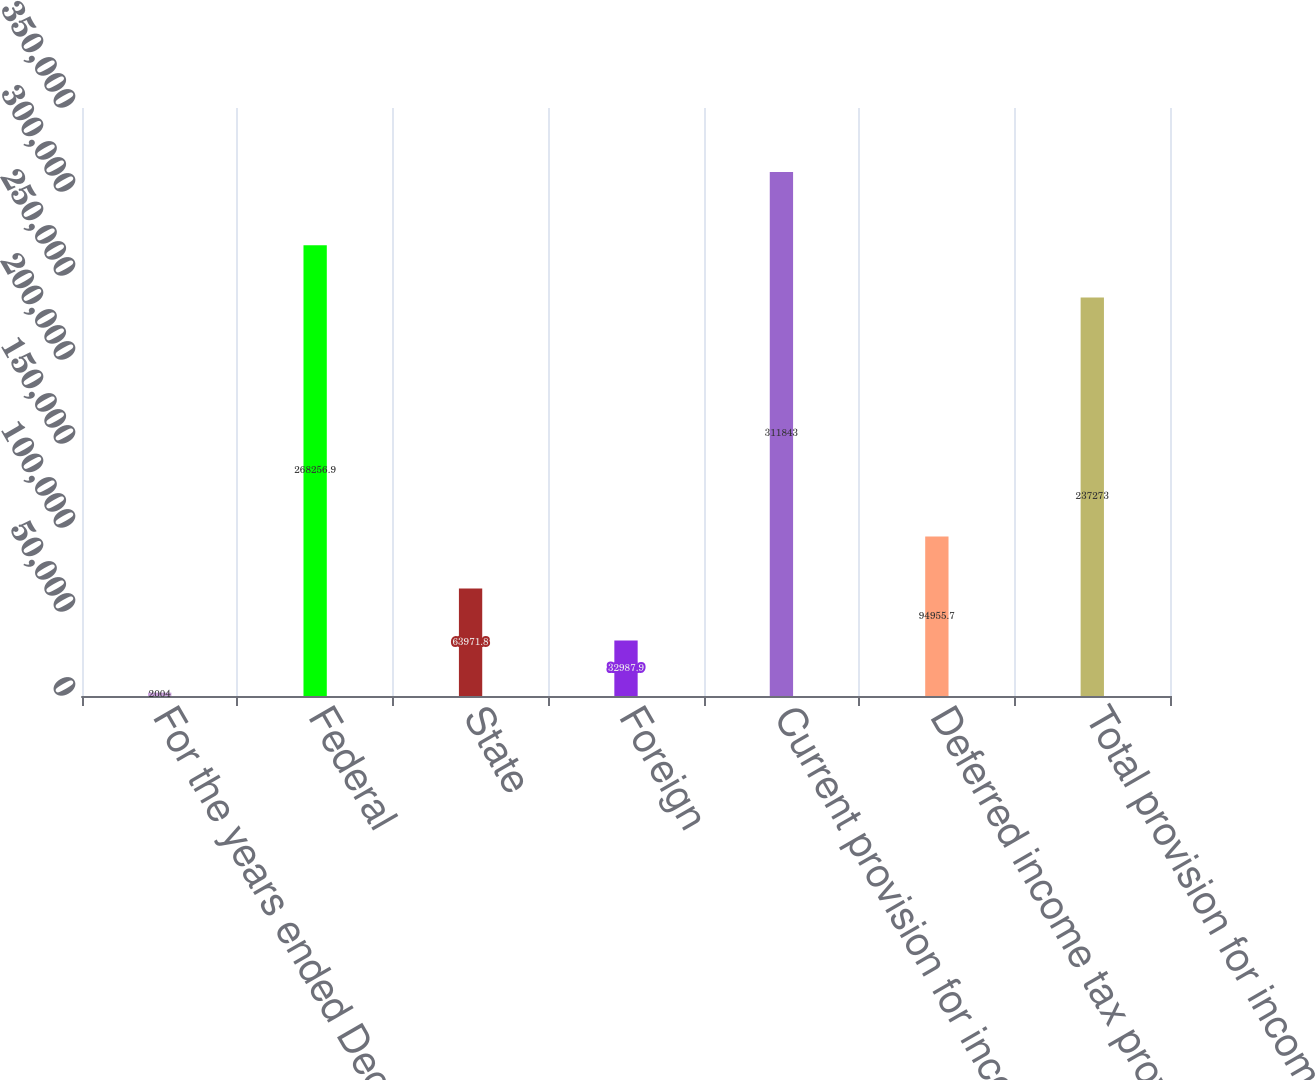<chart> <loc_0><loc_0><loc_500><loc_500><bar_chart><fcel>For the years ended December<fcel>Federal<fcel>State<fcel>Foreign<fcel>Current provision for income<fcel>Deferred income tax provision<fcel>Total provision for income<nl><fcel>2004<fcel>268257<fcel>63971.8<fcel>32987.9<fcel>311843<fcel>94955.7<fcel>237273<nl></chart> 